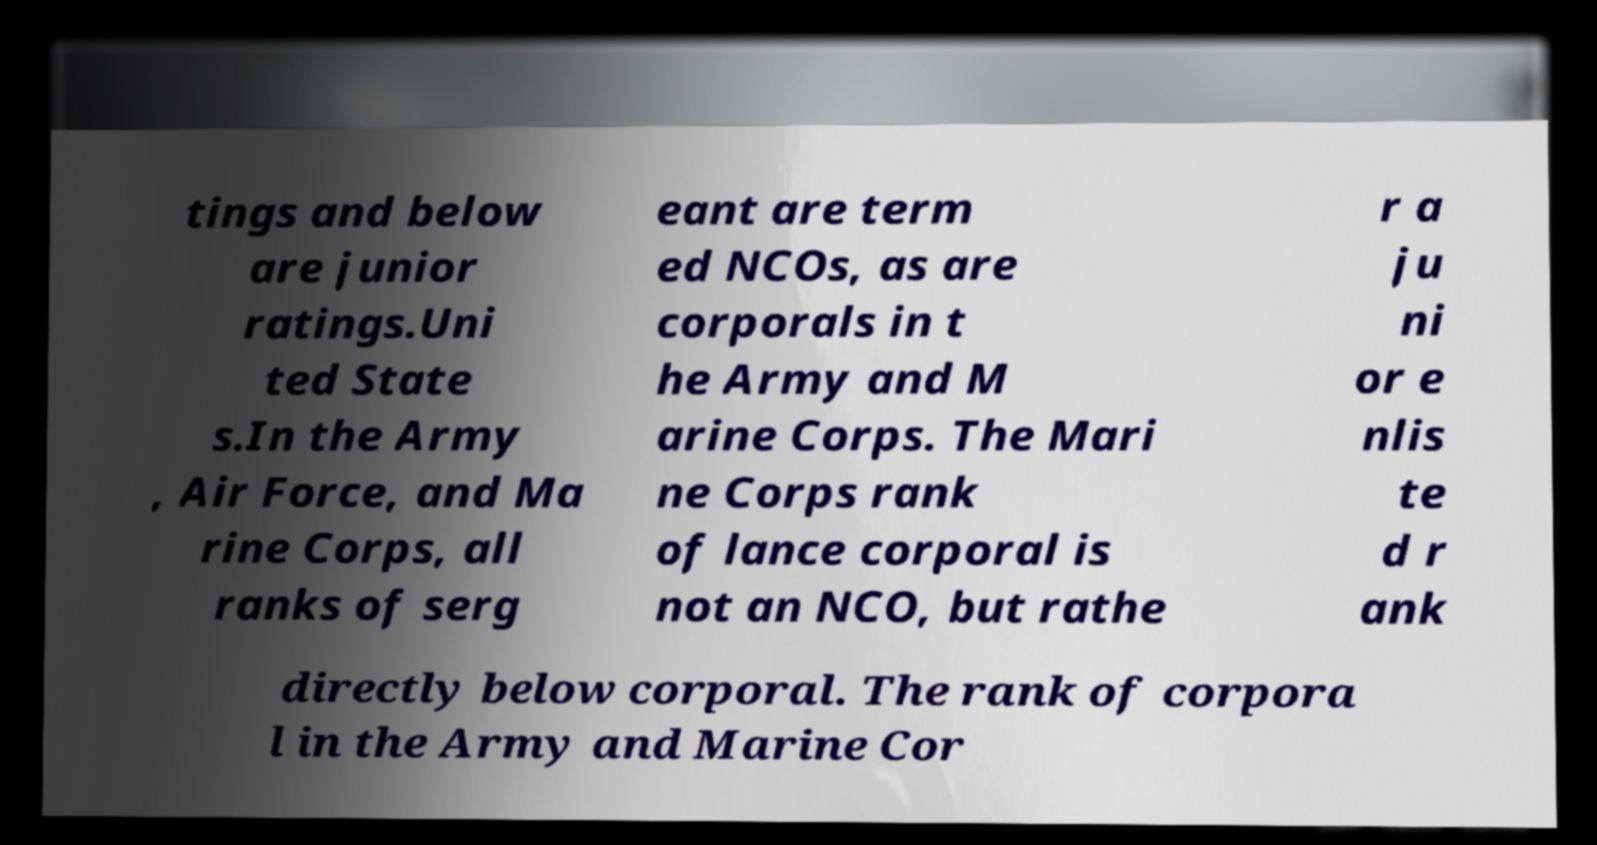Can you accurately transcribe the text from the provided image for me? tings and below are junior ratings.Uni ted State s.In the Army , Air Force, and Ma rine Corps, all ranks of serg eant are term ed NCOs, as are corporals in t he Army and M arine Corps. The Mari ne Corps rank of lance corporal is not an NCO, but rathe r a ju ni or e nlis te d r ank directly below corporal. The rank of corpora l in the Army and Marine Cor 